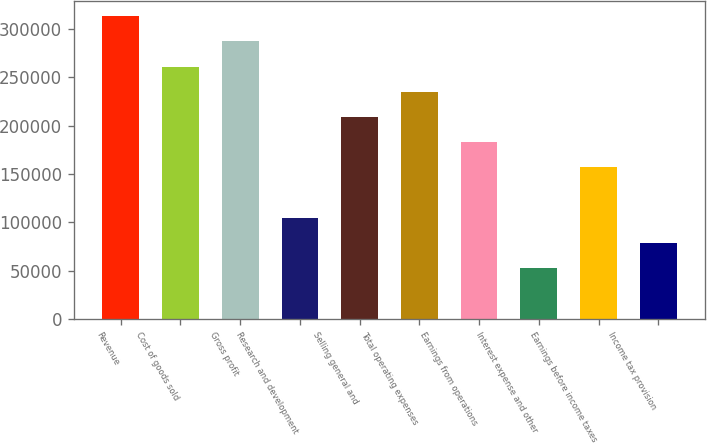Convert chart to OTSL. <chart><loc_0><loc_0><loc_500><loc_500><bar_chart><fcel>Revenue<fcel>Cost of goods sold<fcel>Gross profit<fcel>Research and development<fcel>Selling general and<fcel>Total operating expenses<fcel>Earnings from operations<fcel>Interest expense and other<fcel>Earnings before income taxes<fcel>Income tax provision<nl><fcel>313296<fcel>261080<fcel>287188<fcel>104432<fcel>208864<fcel>234972<fcel>182756<fcel>52216.4<fcel>156648<fcel>78324.4<nl></chart> 